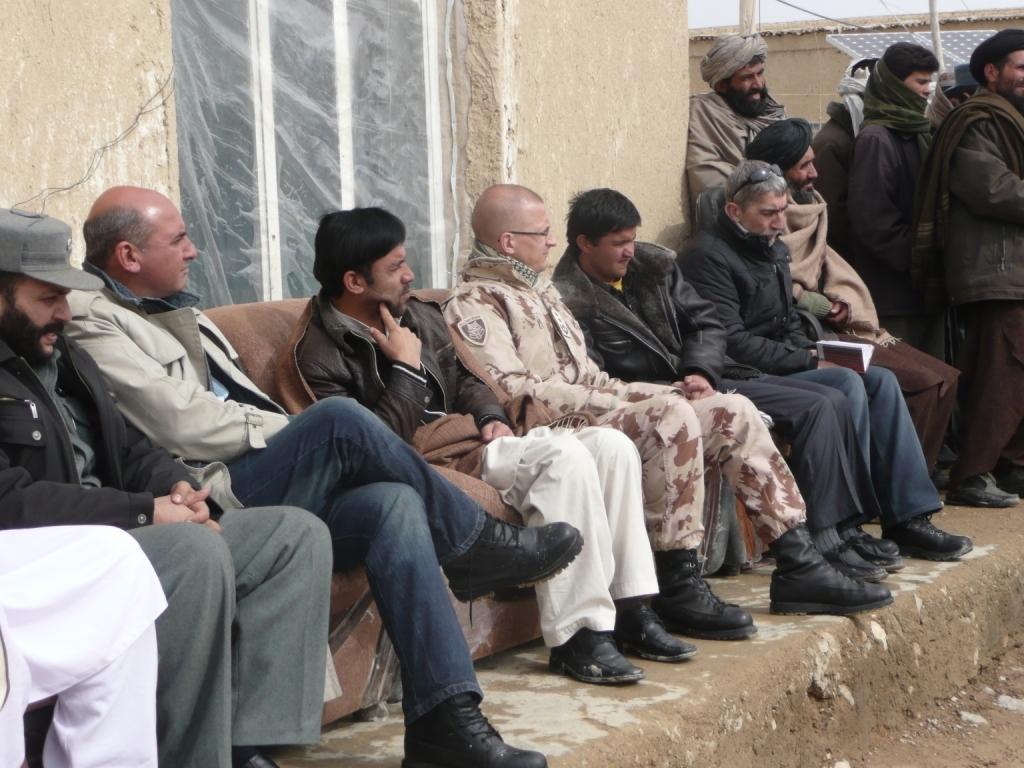Please provide a concise description of this image. In this image in the center there are some people who are sitting on couch, and some of them are standing. In the background there is a window, wall and a house. At the bottom there is a walkway. 